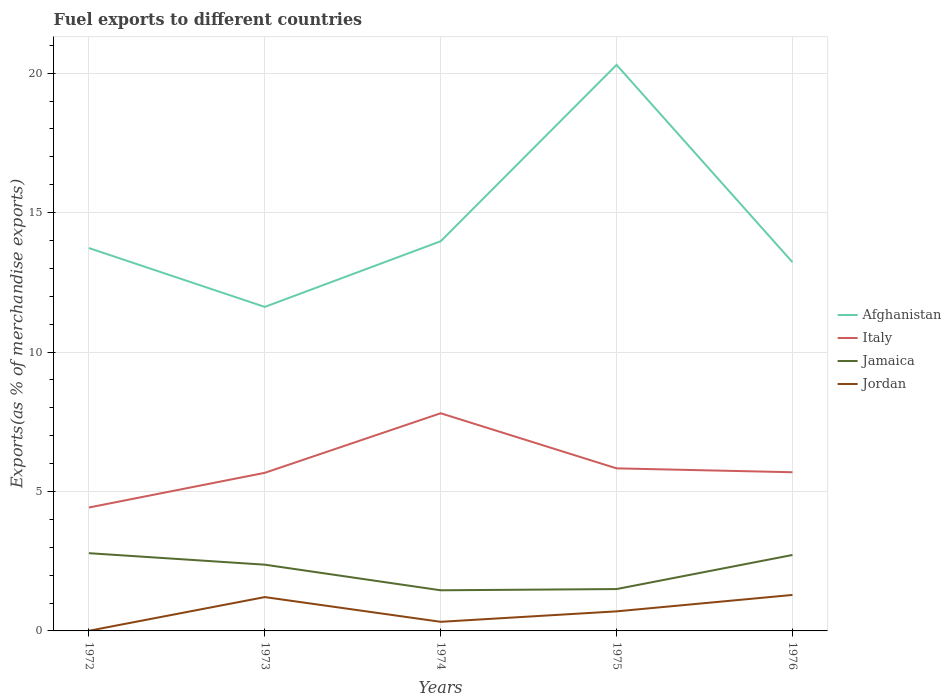Does the line corresponding to Afghanistan intersect with the line corresponding to Italy?
Make the answer very short. No. Is the number of lines equal to the number of legend labels?
Offer a very short reply. Yes. Across all years, what is the maximum percentage of exports to different countries in Italy?
Provide a succinct answer. 4.43. In which year was the percentage of exports to different countries in Jamaica maximum?
Your answer should be compact. 1974. What is the total percentage of exports to different countries in Italy in the graph?
Give a very brief answer. -3.38. What is the difference between the highest and the second highest percentage of exports to different countries in Italy?
Provide a succinct answer. 3.38. Is the percentage of exports to different countries in Afghanistan strictly greater than the percentage of exports to different countries in Jamaica over the years?
Give a very brief answer. No. How many lines are there?
Make the answer very short. 4. How many years are there in the graph?
Provide a short and direct response. 5. How many legend labels are there?
Offer a very short reply. 4. How are the legend labels stacked?
Keep it short and to the point. Vertical. What is the title of the graph?
Your response must be concise. Fuel exports to different countries. What is the label or title of the Y-axis?
Make the answer very short. Exports(as % of merchandise exports). What is the Exports(as % of merchandise exports) in Afghanistan in 1972?
Keep it short and to the point. 13.73. What is the Exports(as % of merchandise exports) in Italy in 1972?
Your answer should be very brief. 4.43. What is the Exports(as % of merchandise exports) in Jamaica in 1972?
Provide a short and direct response. 2.79. What is the Exports(as % of merchandise exports) in Jordan in 1972?
Provide a short and direct response. 0.01. What is the Exports(as % of merchandise exports) of Afghanistan in 1973?
Ensure brevity in your answer.  11.62. What is the Exports(as % of merchandise exports) in Italy in 1973?
Offer a terse response. 5.67. What is the Exports(as % of merchandise exports) of Jamaica in 1973?
Ensure brevity in your answer.  2.38. What is the Exports(as % of merchandise exports) in Jordan in 1973?
Keep it short and to the point. 1.21. What is the Exports(as % of merchandise exports) in Afghanistan in 1974?
Offer a very short reply. 13.97. What is the Exports(as % of merchandise exports) of Italy in 1974?
Your response must be concise. 7.81. What is the Exports(as % of merchandise exports) of Jamaica in 1974?
Keep it short and to the point. 1.46. What is the Exports(as % of merchandise exports) in Jordan in 1974?
Your answer should be compact. 0.33. What is the Exports(as % of merchandise exports) of Afghanistan in 1975?
Offer a terse response. 20.3. What is the Exports(as % of merchandise exports) in Italy in 1975?
Your response must be concise. 5.83. What is the Exports(as % of merchandise exports) in Jamaica in 1975?
Your answer should be very brief. 1.5. What is the Exports(as % of merchandise exports) in Jordan in 1975?
Your answer should be very brief. 0.7. What is the Exports(as % of merchandise exports) of Afghanistan in 1976?
Ensure brevity in your answer.  13.22. What is the Exports(as % of merchandise exports) of Italy in 1976?
Provide a succinct answer. 5.69. What is the Exports(as % of merchandise exports) of Jamaica in 1976?
Your response must be concise. 2.72. What is the Exports(as % of merchandise exports) in Jordan in 1976?
Provide a short and direct response. 1.29. Across all years, what is the maximum Exports(as % of merchandise exports) of Afghanistan?
Offer a terse response. 20.3. Across all years, what is the maximum Exports(as % of merchandise exports) in Italy?
Your response must be concise. 7.81. Across all years, what is the maximum Exports(as % of merchandise exports) in Jamaica?
Offer a very short reply. 2.79. Across all years, what is the maximum Exports(as % of merchandise exports) of Jordan?
Make the answer very short. 1.29. Across all years, what is the minimum Exports(as % of merchandise exports) in Afghanistan?
Offer a terse response. 11.62. Across all years, what is the minimum Exports(as % of merchandise exports) in Italy?
Your response must be concise. 4.43. Across all years, what is the minimum Exports(as % of merchandise exports) in Jamaica?
Make the answer very short. 1.46. Across all years, what is the minimum Exports(as % of merchandise exports) in Jordan?
Keep it short and to the point. 0.01. What is the total Exports(as % of merchandise exports) in Afghanistan in the graph?
Your answer should be very brief. 72.85. What is the total Exports(as % of merchandise exports) in Italy in the graph?
Your response must be concise. 29.42. What is the total Exports(as % of merchandise exports) of Jamaica in the graph?
Offer a very short reply. 10.85. What is the total Exports(as % of merchandise exports) of Jordan in the graph?
Make the answer very short. 3.54. What is the difference between the Exports(as % of merchandise exports) of Afghanistan in 1972 and that in 1973?
Give a very brief answer. 2.11. What is the difference between the Exports(as % of merchandise exports) in Italy in 1972 and that in 1973?
Ensure brevity in your answer.  -1.24. What is the difference between the Exports(as % of merchandise exports) of Jamaica in 1972 and that in 1973?
Ensure brevity in your answer.  0.41. What is the difference between the Exports(as % of merchandise exports) in Jordan in 1972 and that in 1973?
Your answer should be compact. -1.21. What is the difference between the Exports(as % of merchandise exports) in Afghanistan in 1972 and that in 1974?
Provide a short and direct response. -0.24. What is the difference between the Exports(as % of merchandise exports) of Italy in 1972 and that in 1974?
Your answer should be very brief. -3.38. What is the difference between the Exports(as % of merchandise exports) of Jamaica in 1972 and that in 1974?
Provide a short and direct response. 1.33. What is the difference between the Exports(as % of merchandise exports) in Jordan in 1972 and that in 1974?
Provide a succinct answer. -0.32. What is the difference between the Exports(as % of merchandise exports) of Afghanistan in 1972 and that in 1975?
Provide a short and direct response. -6.57. What is the difference between the Exports(as % of merchandise exports) in Italy in 1972 and that in 1975?
Your response must be concise. -1.4. What is the difference between the Exports(as % of merchandise exports) of Jamaica in 1972 and that in 1975?
Keep it short and to the point. 1.29. What is the difference between the Exports(as % of merchandise exports) of Jordan in 1972 and that in 1975?
Your answer should be compact. -0.7. What is the difference between the Exports(as % of merchandise exports) in Afghanistan in 1972 and that in 1976?
Your response must be concise. 0.51. What is the difference between the Exports(as % of merchandise exports) in Italy in 1972 and that in 1976?
Make the answer very short. -1.27. What is the difference between the Exports(as % of merchandise exports) of Jamaica in 1972 and that in 1976?
Your answer should be very brief. 0.06. What is the difference between the Exports(as % of merchandise exports) of Jordan in 1972 and that in 1976?
Ensure brevity in your answer.  -1.28. What is the difference between the Exports(as % of merchandise exports) of Afghanistan in 1973 and that in 1974?
Provide a short and direct response. -2.35. What is the difference between the Exports(as % of merchandise exports) in Italy in 1973 and that in 1974?
Your answer should be compact. -2.14. What is the difference between the Exports(as % of merchandise exports) of Jamaica in 1973 and that in 1974?
Your response must be concise. 0.92. What is the difference between the Exports(as % of merchandise exports) of Jordan in 1973 and that in 1974?
Offer a very short reply. 0.89. What is the difference between the Exports(as % of merchandise exports) in Afghanistan in 1973 and that in 1975?
Keep it short and to the point. -8.68. What is the difference between the Exports(as % of merchandise exports) of Italy in 1973 and that in 1975?
Make the answer very short. -0.16. What is the difference between the Exports(as % of merchandise exports) of Jamaica in 1973 and that in 1975?
Ensure brevity in your answer.  0.87. What is the difference between the Exports(as % of merchandise exports) in Jordan in 1973 and that in 1975?
Ensure brevity in your answer.  0.51. What is the difference between the Exports(as % of merchandise exports) in Afghanistan in 1973 and that in 1976?
Ensure brevity in your answer.  -1.6. What is the difference between the Exports(as % of merchandise exports) of Italy in 1973 and that in 1976?
Offer a terse response. -0.02. What is the difference between the Exports(as % of merchandise exports) in Jamaica in 1973 and that in 1976?
Your answer should be very brief. -0.35. What is the difference between the Exports(as % of merchandise exports) of Jordan in 1973 and that in 1976?
Your answer should be compact. -0.08. What is the difference between the Exports(as % of merchandise exports) of Afghanistan in 1974 and that in 1975?
Make the answer very short. -6.33. What is the difference between the Exports(as % of merchandise exports) in Italy in 1974 and that in 1975?
Make the answer very short. 1.98. What is the difference between the Exports(as % of merchandise exports) in Jamaica in 1974 and that in 1975?
Your answer should be very brief. -0.04. What is the difference between the Exports(as % of merchandise exports) in Jordan in 1974 and that in 1975?
Give a very brief answer. -0.38. What is the difference between the Exports(as % of merchandise exports) in Italy in 1974 and that in 1976?
Your response must be concise. 2.12. What is the difference between the Exports(as % of merchandise exports) in Jamaica in 1974 and that in 1976?
Offer a terse response. -1.27. What is the difference between the Exports(as % of merchandise exports) in Jordan in 1974 and that in 1976?
Provide a short and direct response. -0.96. What is the difference between the Exports(as % of merchandise exports) in Afghanistan in 1975 and that in 1976?
Keep it short and to the point. 7.08. What is the difference between the Exports(as % of merchandise exports) of Italy in 1975 and that in 1976?
Keep it short and to the point. 0.14. What is the difference between the Exports(as % of merchandise exports) of Jamaica in 1975 and that in 1976?
Your answer should be very brief. -1.22. What is the difference between the Exports(as % of merchandise exports) in Jordan in 1975 and that in 1976?
Provide a short and direct response. -0.59. What is the difference between the Exports(as % of merchandise exports) of Afghanistan in 1972 and the Exports(as % of merchandise exports) of Italy in 1973?
Give a very brief answer. 8.06. What is the difference between the Exports(as % of merchandise exports) in Afghanistan in 1972 and the Exports(as % of merchandise exports) in Jamaica in 1973?
Your answer should be very brief. 11.36. What is the difference between the Exports(as % of merchandise exports) in Afghanistan in 1972 and the Exports(as % of merchandise exports) in Jordan in 1973?
Make the answer very short. 12.52. What is the difference between the Exports(as % of merchandise exports) of Italy in 1972 and the Exports(as % of merchandise exports) of Jamaica in 1973?
Make the answer very short. 2.05. What is the difference between the Exports(as % of merchandise exports) in Italy in 1972 and the Exports(as % of merchandise exports) in Jordan in 1973?
Ensure brevity in your answer.  3.21. What is the difference between the Exports(as % of merchandise exports) in Jamaica in 1972 and the Exports(as % of merchandise exports) in Jordan in 1973?
Make the answer very short. 1.57. What is the difference between the Exports(as % of merchandise exports) of Afghanistan in 1972 and the Exports(as % of merchandise exports) of Italy in 1974?
Provide a short and direct response. 5.92. What is the difference between the Exports(as % of merchandise exports) in Afghanistan in 1972 and the Exports(as % of merchandise exports) in Jamaica in 1974?
Provide a short and direct response. 12.27. What is the difference between the Exports(as % of merchandise exports) of Afghanistan in 1972 and the Exports(as % of merchandise exports) of Jordan in 1974?
Provide a succinct answer. 13.4. What is the difference between the Exports(as % of merchandise exports) in Italy in 1972 and the Exports(as % of merchandise exports) in Jamaica in 1974?
Keep it short and to the point. 2.97. What is the difference between the Exports(as % of merchandise exports) in Italy in 1972 and the Exports(as % of merchandise exports) in Jordan in 1974?
Offer a very short reply. 4.1. What is the difference between the Exports(as % of merchandise exports) of Jamaica in 1972 and the Exports(as % of merchandise exports) of Jordan in 1974?
Your answer should be compact. 2.46. What is the difference between the Exports(as % of merchandise exports) of Afghanistan in 1972 and the Exports(as % of merchandise exports) of Italy in 1975?
Make the answer very short. 7.9. What is the difference between the Exports(as % of merchandise exports) in Afghanistan in 1972 and the Exports(as % of merchandise exports) in Jamaica in 1975?
Ensure brevity in your answer.  12.23. What is the difference between the Exports(as % of merchandise exports) of Afghanistan in 1972 and the Exports(as % of merchandise exports) of Jordan in 1975?
Offer a terse response. 13.03. What is the difference between the Exports(as % of merchandise exports) in Italy in 1972 and the Exports(as % of merchandise exports) in Jamaica in 1975?
Your answer should be compact. 2.92. What is the difference between the Exports(as % of merchandise exports) in Italy in 1972 and the Exports(as % of merchandise exports) in Jordan in 1975?
Provide a short and direct response. 3.72. What is the difference between the Exports(as % of merchandise exports) in Jamaica in 1972 and the Exports(as % of merchandise exports) in Jordan in 1975?
Your answer should be very brief. 2.09. What is the difference between the Exports(as % of merchandise exports) of Afghanistan in 1972 and the Exports(as % of merchandise exports) of Italy in 1976?
Keep it short and to the point. 8.04. What is the difference between the Exports(as % of merchandise exports) of Afghanistan in 1972 and the Exports(as % of merchandise exports) of Jamaica in 1976?
Make the answer very short. 11.01. What is the difference between the Exports(as % of merchandise exports) of Afghanistan in 1972 and the Exports(as % of merchandise exports) of Jordan in 1976?
Offer a terse response. 12.44. What is the difference between the Exports(as % of merchandise exports) in Italy in 1972 and the Exports(as % of merchandise exports) in Jamaica in 1976?
Offer a terse response. 1.7. What is the difference between the Exports(as % of merchandise exports) in Italy in 1972 and the Exports(as % of merchandise exports) in Jordan in 1976?
Provide a succinct answer. 3.14. What is the difference between the Exports(as % of merchandise exports) of Jamaica in 1972 and the Exports(as % of merchandise exports) of Jordan in 1976?
Your answer should be compact. 1.5. What is the difference between the Exports(as % of merchandise exports) of Afghanistan in 1973 and the Exports(as % of merchandise exports) of Italy in 1974?
Your answer should be very brief. 3.81. What is the difference between the Exports(as % of merchandise exports) of Afghanistan in 1973 and the Exports(as % of merchandise exports) of Jamaica in 1974?
Make the answer very short. 10.16. What is the difference between the Exports(as % of merchandise exports) in Afghanistan in 1973 and the Exports(as % of merchandise exports) in Jordan in 1974?
Keep it short and to the point. 11.29. What is the difference between the Exports(as % of merchandise exports) of Italy in 1973 and the Exports(as % of merchandise exports) of Jamaica in 1974?
Ensure brevity in your answer.  4.21. What is the difference between the Exports(as % of merchandise exports) in Italy in 1973 and the Exports(as % of merchandise exports) in Jordan in 1974?
Keep it short and to the point. 5.34. What is the difference between the Exports(as % of merchandise exports) in Jamaica in 1973 and the Exports(as % of merchandise exports) in Jordan in 1974?
Provide a short and direct response. 2.05. What is the difference between the Exports(as % of merchandise exports) of Afghanistan in 1973 and the Exports(as % of merchandise exports) of Italy in 1975?
Offer a terse response. 5.79. What is the difference between the Exports(as % of merchandise exports) of Afghanistan in 1973 and the Exports(as % of merchandise exports) of Jamaica in 1975?
Your answer should be very brief. 10.12. What is the difference between the Exports(as % of merchandise exports) of Afghanistan in 1973 and the Exports(as % of merchandise exports) of Jordan in 1975?
Your answer should be very brief. 10.92. What is the difference between the Exports(as % of merchandise exports) of Italy in 1973 and the Exports(as % of merchandise exports) of Jamaica in 1975?
Give a very brief answer. 4.17. What is the difference between the Exports(as % of merchandise exports) of Italy in 1973 and the Exports(as % of merchandise exports) of Jordan in 1975?
Your answer should be very brief. 4.97. What is the difference between the Exports(as % of merchandise exports) in Jamaica in 1973 and the Exports(as % of merchandise exports) in Jordan in 1975?
Ensure brevity in your answer.  1.67. What is the difference between the Exports(as % of merchandise exports) in Afghanistan in 1973 and the Exports(as % of merchandise exports) in Italy in 1976?
Offer a very short reply. 5.93. What is the difference between the Exports(as % of merchandise exports) in Afghanistan in 1973 and the Exports(as % of merchandise exports) in Jamaica in 1976?
Give a very brief answer. 8.9. What is the difference between the Exports(as % of merchandise exports) of Afghanistan in 1973 and the Exports(as % of merchandise exports) of Jordan in 1976?
Provide a short and direct response. 10.33. What is the difference between the Exports(as % of merchandise exports) of Italy in 1973 and the Exports(as % of merchandise exports) of Jamaica in 1976?
Your answer should be very brief. 2.95. What is the difference between the Exports(as % of merchandise exports) of Italy in 1973 and the Exports(as % of merchandise exports) of Jordan in 1976?
Your answer should be very brief. 4.38. What is the difference between the Exports(as % of merchandise exports) in Jamaica in 1973 and the Exports(as % of merchandise exports) in Jordan in 1976?
Provide a short and direct response. 1.09. What is the difference between the Exports(as % of merchandise exports) of Afghanistan in 1974 and the Exports(as % of merchandise exports) of Italy in 1975?
Provide a succinct answer. 8.14. What is the difference between the Exports(as % of merchandise exports) of Afghanistan in 1974 and the Exports(as % of merchandise exports) of Jamaica in 1975?
Give a very brief answer. 12.47. What is the difference between the Exports(as % of merchandise exports) in Afghanistan in 1974 and the Exports(as % of merchandise exports) in Jordan in 1975?
Provide a short and direct response. 13.27. What is the difference between the Exports(as % of merchandise exports) of Italy in 1974 and the Exports(as % of merchandise exports) of Jamaica in 1975?
Offer a very short reply. 6.3. What is the difference between the Exports(as % of merchandise exports) in Italy in 1974 and the Exports(as % of merchandise exports) in Jordan in 1975?
Make the answer very short. 7.1. What is the difference between the Exports(as % of merchandise exports) in Jamaica in 1974 and the Exports(as % of merchandise exports) in Jordan in 1975?
Keep it short and to the point. 0.76. What is the difference between the Exports(as % of merchandise exports) of Afghanistan in 1974 and the Exports(as % of merchandise exports) of Italy in 1976?
Offer a very short reply. 8.28. What is the difference between the Exports(as % of merchandise exports) of Afghanistan in 1974 and the Exports(as % of merchandise exports) of Jamaica in 1976?
Offer a terse response. 11.25. What is the difference between the Exports(as % of merchandise exports) of Afghanistan in 1974 and the Exports(as % of merchandise exports) of Jordan in 1976?
Provide a succinct answer. 12.68. What is the difference between the Exports(as % of merchandise exports) of Italy in 1974 and the Exports(as % of merchandise exports) of Jamaica in 1976?
Offer a terse response. 5.08. What is the difference between the Exports(as % of merchandise exports) of Italy in 1974 and the Exports(as % of merchandise exports) of Jordan in 1976?
Give a very brief answer. 6.52. What is the difference between the Exports(as % of merchandise exports) of Jamaica in 1974 and the Exports(as % of merchandise exports) of Jordan in 1976?
Provide a short and direct response. 0.17. What is the difference between the Exports(as % of merchandise exports) in Afghanistan in 1975 and the Exports(as % of merchandise exports) in Italy in 1976?
Provide a short and direct response. 14.61. What is the difference between the Exports(as % of merchandise exports) of Afghanistan in 1975 and the Exports(as % of merchandise exports) of Jamaica in 1976?
Make the answer very short. 17.58. What is the difference between the Exports(as % of merchandise exports) of Afghanistan in 1975 and the Exports(as % of merchandise exports) of Jordan in 1976?
Give a very brief answer. 19.01. What is the difference between the Exports(as % of merchandise exports) of Italy in 1975 and the Exports(as % of merchandise exports) of Jamaica in 1976?
Keep it short and to the point. 3.11. What is the difference between the Exports(as % of merchandise exports) in Italy in 1975 and the Exports(as % of merchandise exports) in Jordan in 1976?
Your answer should be very brief. 4.54. What is the difference between the Exports(as % of merchandise exports) of Jamaica in 1975 and the Exports(as % of merchandise exports) of Jordan in 1976?
Offer a terse response. 0.21. What is the average Exports(as % of merchandise exports) of Afghanistan per year?
Keep it short and to the point. 14.57. What is the average Exports(as % of merchandise exports) of Italy per year?
Your answer should be compact. 5.88. What is the average Exports(as % of merchandise exports) in Jamaica per year?
Your response must be concise. 2.17. What is the average Exports(as % of merchandise exports) of Jordan per year?
Offer a terse response. 0.71. In the year 1972, what is the difference between the Exports(as % of merchandise exports) of Afghanistan and Exports(as % of merchandise exports) of Italy?
Offer a terse response. 9.31. In the year 1972, what is the difference between the Exports(as % of merchandise exports) in Afghanistan and Exports(as % of merchandise exports) in Jamaica?
Keep it short and to the point. 10.94. In the year 1972, what is the difference between the Exports(as % of merchandise exports) in Afghanistan and Exports(as % of merchandise exports) in Jordan?
Ensure brevity in your answer.  13.73. In the year 1972, what is the difference between the Exports(as % of merchandise exports) of Italy and Exports(as % of merchandise exports) of Jamaica?
Keep it short and to the point. 1.64. In the year 1972, what is the difference between the Exports(as % of merchandise exports) in Italy and Exports(as % of merchandise exports) in Jordan?
Your response must be concise. 4.42. In the year 1972, what is the difference between the Exports(as % of merchandise exports) of Jamaica and Exports(as % of merchandise exports) of Jordan?
Offer a terse response. 2.78. In the year 1973, what is the difference between the Exports(as % of merchandise exports) in Afghanistan and Exports(as % of merchandise exports) in Italy?
Your answer should be very brief. 5.95. In the year 1973, what is the difference between the Exports(as % of merchandise exports) of Afghanistan and Exports(as % of merchandise exports) of Jamaica?
Your answer should be compact. 9.24. In the year 1973, what is the difference between the Exports(as % of merchandise exports) in Afghanistan and Exports(as % of merchandise exports) in Jordan?
Your answer should be compact. 10.41. In the year 1973, what is the difference between the Exports(as % of merchandise exports) of Italy and Exports(as % of merchandise exports) of Jamaica?
Give a very brief answer. 3.29. In the year 1973, what is the difference between the Exports(as % of merchandise exports) of Italy and Exports(as % of merchandise exports) of Jordan?
Ensure brevity in your answer.  4.46. In the year 1973, what is the difference between the Exports(as % of merchandise exports) in Jamaica and Exports(as % of merchandise exports) in Jordan?
Your answer should be compact. 1.16. In the year 1974, what is the difference between the Exports(as % of merchandise exports) of Afghanistan and Exports(as % of merchandise exports) of Italy?
Your response must be concise. 6.17. In the year 1974, what is the difference between the Exports(as % of merchandise exports) of Afghanistan and Exports(as % of merchandise exports) of Jamaica?
Make the answer very short. 12.52. In the year 1974, what is the difference between the Exports(as % of merchandise exports) in Afghanistan and Exports(as % of merchandise exports) in Jordan?
Give a very brief answer. 13.65. In the year 1974, what is the difference between the Exports(as % of merchandise exports) of Italy and Exports(as % of merchandise exports) of Jamaica?
Your answer should be compact. 6.35. In the year 1974, what is the difference between the Exports(as % of merchandise exports) in Italy and Exports(as % of merchandise exports) in Jordan?
Ensure brevity in your answer.  7.48. In the year 1974, what is the difference between the Exports(as % of merchandise exports) of Jamaica and Exports(as % of merchandise exports) of Jordan?
Give a very brief answer. 1.13. In the year 1975, what is the difference between the Exports(as % of merchandise exports) in Afghanistan and Exports(as % of merchandise exports) in Italy?
Give a very brief answer. 14.47. In the year 1975, what is the difference between the Exports(as % of merchandise exports) in Afghanistan and Exports(as % of merchandise exports) in Jamaica?
Make the answer very short. 18.8. In the year 1975, what is the difference between the Exports(as % of merchandise exports) in Afghanistan and Exports(as % of merchandise exports) in Jordan?
Your answer should be very brief. 19.6. In the year 1975, what is the difference between the Exports(as % of merchandise exports) of Italy and Exports(as % of merchandise exports) of Jamaica?
Give a very brief answer. 4.33. In the year 1975, what is the difference between the Exports(as % of merchandise exports) of Italy and Exports(as % of merchandise exports) of Jordan?
Offer a very short reply. 5.13. In the year 1975, what is the difference between the Exports(as % of merchandise exports) of Jamaica and Exports(as % of merchandise exports) of Jordan?
Offer a terse response. 0.8. In the year 1976, what is the difference between the Exports(as % of merchandise exports) in Afghanistan and Exports(as % of merchandise exports) in Italy?
Make the answer very short. 7.53. In the year 1976, what is the difference between the Exports(as % of merchandise exports) of Afghanistan and Exports(as % of merchandise exports) of Jamaica?
Keep it short and to the point. 10.5. In the year 1976, what is the difference between the Exports(as % of merchandise exports) in Afghanistan and Exports(as % of merchandise exports) in Jordan?
Your response must be concise. 11.93. In the year 1976, what is the difference between the Exports(as % of merchandise exports) in Italy and Exports(as % of merchandise exports) in Jamaica?
Provide a short and direct response. 2.97. In the year 1976, what is the difference between the Exports(as % of merchandise exports) of Italy and Exports(as % of merchandise exports) of Jordan?
Your response must be concise. 4.4. In the year 1976, what is the difference between the Exports(as % of merchandise exports) in Jamaica and Exports(as % of merchandise exports) in Jordan?
Offer a very short reply. 1.43. What is the ratio of the Exports(as % of merchandise exports) in Afghanistan in 1972 to that in 1973?
Make the answer very short. 1.18. What is the ratio of the Exports(as % of merchandise exports) of Italy in 1972 to that in 1973?
Provide a short and direct response. 0.78. What is the ratio of the Exports(as % of merchandise exports) of Jamaica in 1972 to that in 1973?
Ensure brevity in your answer.  1.17. What is the ratio of the Exports(as % of merchandise exports) in Jordan in 1972 to that in 1973?
Give a very brief answer. 0. What is the ratio of the Exports(as % of merchandise exports) of Afghanistan in 1972 to that in 1974?
Your answer should be very brief. 0.98. What is the ratio of the Exports(as % of merchandise exports) in Italy in 1972 to that in 1974?
Your answer should be very brief. 0.57. What is the ratio of the Exports(as % of merchandise exports) of Jamaica in 1972 to that in 1974?
Your response must be concise. 1.91. What is the ratio of the Exports(as % of merchandise exports) in Jordan in 1972 to that in 1974?
Keep it short and to the point. 0.02. What is the ratio of the Exports(as % of merchandise exports) of Afghanistan in 1972 to that in 1975?
Provide a succinct answer. 0.68. What is the ratio of the Exports(as % of merchandise exports) of Italy in 1972 to that in 1975?
Make the answer very short. 0.76. What is the ratio of the Exports(as % of merchandise exports) in Jamaica in 1972 to that in 1975?
Your response must be concise. 1.86. What is the ratio of the Exports(as % of merchandise exports) in Jordan in 1972 to that in 1975?
Give a very brief answer. 0.01. What is the ratio of the Exports(as % of merchandise exports) of Afghanistan in 1972 to that in 1976?
Your answer should be very brief. 1.04. What is the ratio of the Exports(as % of merchandise exports) of Italy in 1972 to that in 1976?
Keep it short and to the point. 0.78. What is the ratio of the Exports(as % of merchandise exports) in Jamaica in 1972 to that in 1976?
Your answer should be compact. 1.02. What is the ratio of the Exports(as % of merchandise exports) in Jordan in 1972 to that in 1976?
Your answer should be compact. 0. What is the ratio of the Exports(as % of merchandise exports) of Afghanistan in 1973 to that in 1974?
Your answer should be compact. 0.83. What is the ratio of the Exports(as % of merchandise exports) of Italy in 1973 to that in 1974?
Provide a succinct answer. 0.73. What is the ratio of the Exports(as % of merchandise exports) in Jamaica in 1973 to that in 1974?
Give a very brief answer. 1.63. What is the ratio of the Exports(as % of merchandise exports) of Jordan in 1973 to that in 1974?
Your answer should be compact. 3.71. What is the ratio of the Exports(as % of merchandise exports) of Afghanistan in 1973 to that in 1975?
Ensure brevity in your answer.  0.57. What is the ratio of the Exports(as % of merchandise exports) of Italy in 1973 to that in 1975?
Your answer should be very brief. 0.97. What is the ratio of the Exports(as % of merchandise exports) of Jamaica in 1973 to that in 1975?
Ensure brevity in your answer.  1.58. What is the ratio of the Exports(as % of merchandise exports) of Jordan in 1973 to that in 1975?
Give a very brief answer. 1.73. What is the ratio of the Exports(as % of merchandise exports) of Afghanistan in 1973 to that in 1976?
Ensure brevity in your answer.  0.88. What is the ratio of the Exports(as % of merchandise exports) in Italy in 1973 to that in 1976?
Keep it short and to the point. 1. What is the ratio of the Exports(as % of merchandise exports) of Jamaica in 1973 to that in 1976?
Provide a succinct answer. 0.87. What is the ratio of the Exports(as % of merchandise exports) of Jordan in 1973 to that in 1976?
Your response must be concise. 0.94. What is the ratio of the Exports(as % of merchandise exports) of Afghanistan in 1974 to that in 1975?
Your response must be concise. 0.69. What is the ratio of the Exports(as % of merchandise exports) of Italy in 1974 to that in 1975?
Your answer should be very brief. 1.34. What is the ratio of the Exports(as % of merchandise exports) of Jamaica in 1974 to that in 1975?
Offer a terse response. 0.97. What is the ratio of the Exports(as % of merchandise exports) of Jordan in 1974 to that in 1975?
Ensure brevity in your answer.  0.47. What is the ratio of the Exports(as % of merchandise exports) of Afghanistan in 1974 to that in 1976?
Give a very brief answer. 1.06. What is the ratio of the Exports(as % of merchandise exports) in Italy in 1974 to that in 1976?
Keep it short and to the point. 1.37. What is the ratio of the Exports(as % of merchandise exports) in Jamaica in 1974 to that in 1976?
Make the answer very short. 0.54. What is the ratio of the Exports(as % of merchandise exports) of Jordan in 1974 to that in 1976?
Make the answer very short. 0.25. What is the ratio of the Exports(as % of merchandise exports) of Afghanistan in 1975 to that in 1976?
Provide a succinct answer. 1.53. What is the ratio of the Exports(as % of merchandise exports) of Italy in 1975 to that in 1976?
Ensure brevity in your answer.  1.02. What is the ratio of the Exports(as % of merchandise exports) in Jamaica in 1975 to that in 1976?
Provide a short and direct response. 0.55. What is the ratio of the Exports(as % of merchandise exports) in Jordan in 1975 to that in 1976?
Your answer should be very brief. 0.54. What is the difference between the highest and the second highest Exports(as % of merchandise exports) in Afghanistan?
Make the answer very short. 6.33. What is the difference between the highest and the second highest Exports(as % of merchandise exports) of Italy?
Your answer should be compact. 1.98. What is the difference between the highest and the second highest Exports(as % of merchandise exports) of Jamaica?
Ensure brevity in your answer.  0.06. What is the difference between the highest and the second highest Exports(as % of merchandise exports) of Jordan?
Offer a terse response. 0.08. What is the difference between the highest and the lowest Exports(as % of merchandise exports) in Afghanistan?
Offer a terse response. 8.68. What is the difference between the highest and the lowest Exports(as % of merchandise exports) in Italy?
Your answer should be compact. 3.38. What is the difference between the highest and the lowest Exports(as % of merchandise exports) in Jamaica?
Provide a succinct answer. 1.33. What is the difference between the highest and the lowest Exports(as % of merchandise exports) of Jordan?
Provide a succinct answer. 1.28. 